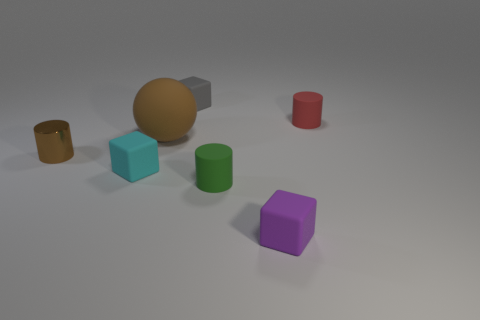What shape is the object that is in front of the small rubber cylinder in front of the brown metallic cylinder? The object in front of the small rubber cylinder, which is front of the brown metallic cylinder, is a cube. Specifically, it's a purple cube with its sides reflecting a soft light, indicating that the cube has a matte surface. 